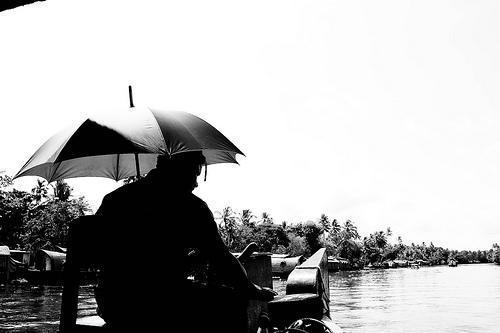How many umbrellas are there?
Give a very brief answer. 1. 